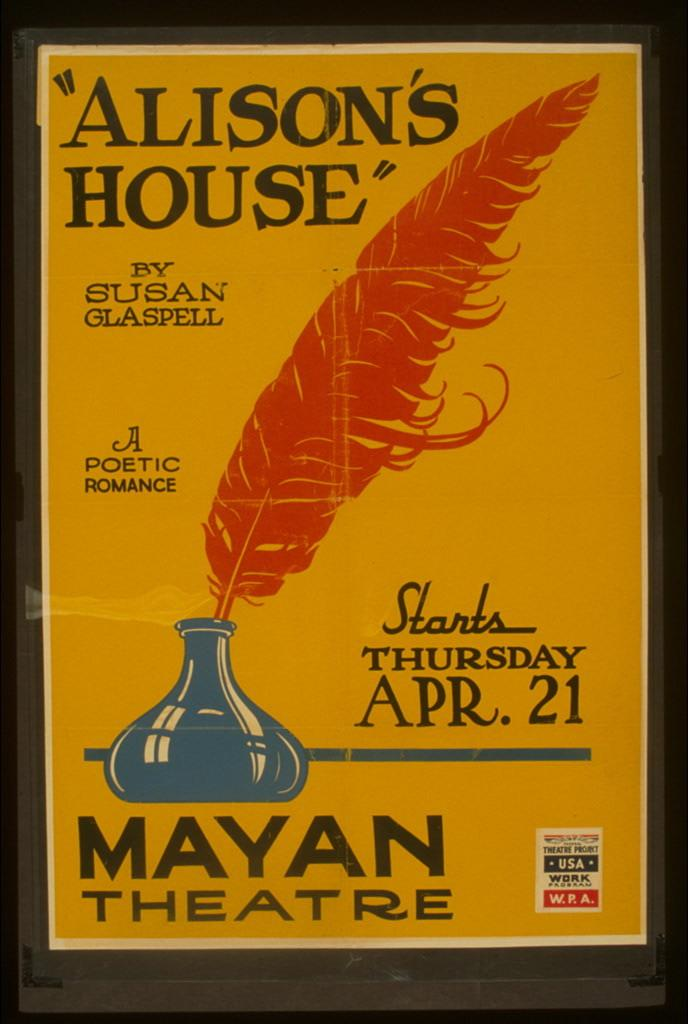Provide a one-sentence caption for the provided image. A yellow and orange poster advertising the play Alisons House at the Mayan Theatre in April. 